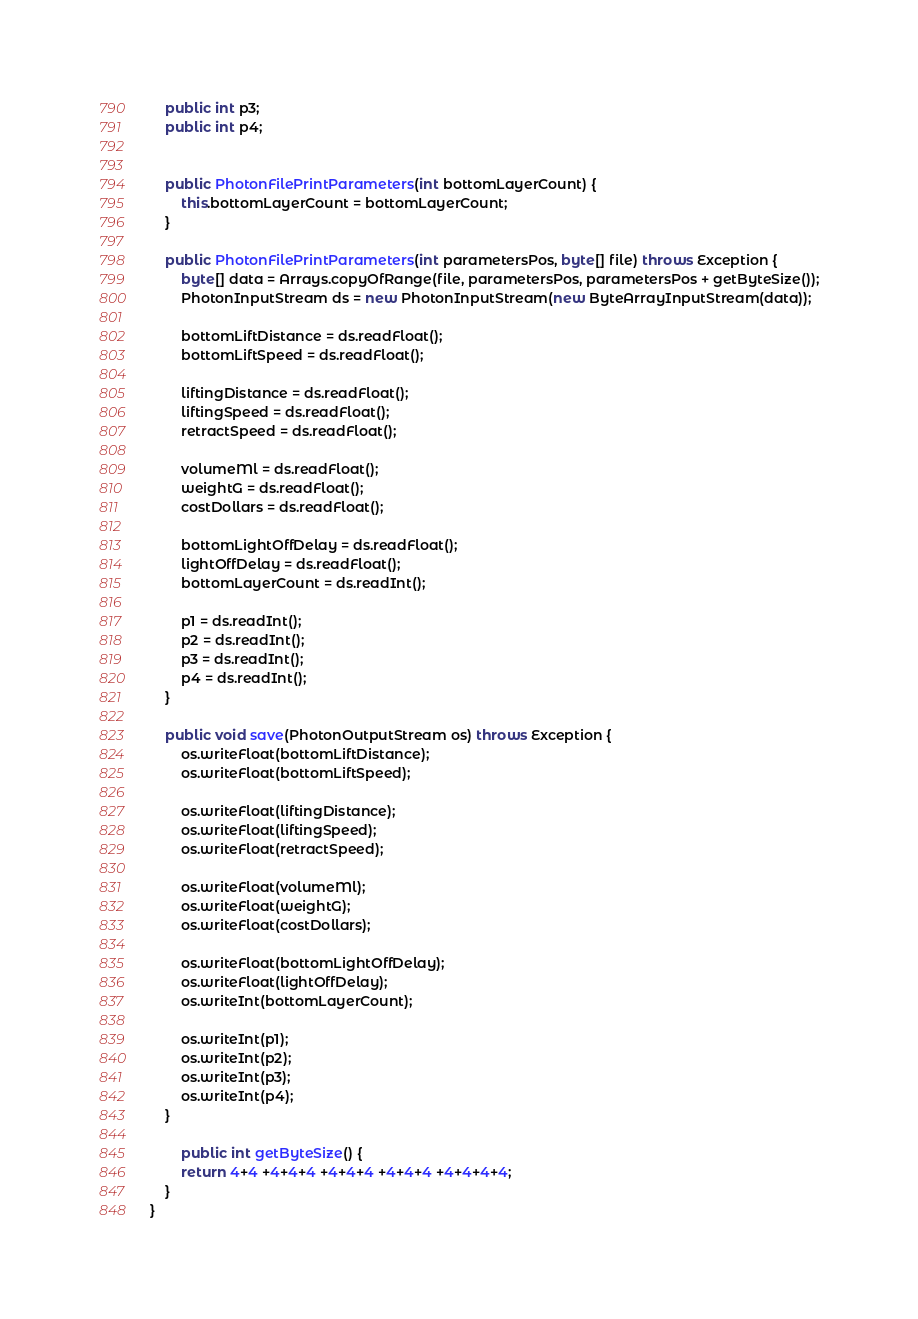<code> <loc_0><loc_0><loc_500><loc_500><_Java_>    public int p3;
    public int p4;


    public PhotonFilePrintParameters(int bottomLayerCount) {
        this.bottomLayerCount = bottomLayerCount;
    }

    public PhotonFilePrintParameters(int parametersPos, byte[] file) throws Exception {
        byte[] data = Arrays.copyOfRange(file, parametersPos, parametersPos + getByteSize());
        PhotonInputStream ds = new PhotonInputStream(new ByteArrayInputStream(data));

        bottomLiftDistance = ds.readFloat();
        bottomLiftSpeed = ds.readFloat();

        liftingDistance = ds.readFloat();
        liftingSpeed = ds.readFloat();
        retractSpeed = ds.readFloat();

        volumeMl = ds.readFloat();
        weightG = ds.readFloat();
        costDollars = ds.readFloat();

        bottomLightOffDelay = ds.readFloat();
        lightOffDelay = ds.readFloat();
        bottomLayerCount = ds.readInt();

        p1 = ds.readInt();
        p2 = ds.readInt();
        p3 = ds.readInt();
        p4 = ds.readInt();
    }

    public void save(PhotonOutputStream os) throws Exception {
        os.writeFloat(bottomLiftDistance);
        os.writeFloat(bottomLiftSpeed);

        os.writeFloat(liftingDistance);
        os.writeFloat(liftingSpeed);
        os.writeFloat(retractSpeed);

        os.writeFloat(volumeMl);
        os.writeFloat(weightG);
        os.writeFloat(costDollars);

        os.writeFloat(bottomLightOffDelay);
        os.writeFloat(lightOffDelay);
        os.writeInt(bottomLayerCount);

        os.writeInt(p1);
        os.writeInt(p2);
        os.writeInt(p3);
        os.writeInt(p4);
    }

        public int getByteSize() {
        return 4+4 +4+4+4 +4+4+4 +4+4+4 +4+4+4+4;
    }
}
</code> 